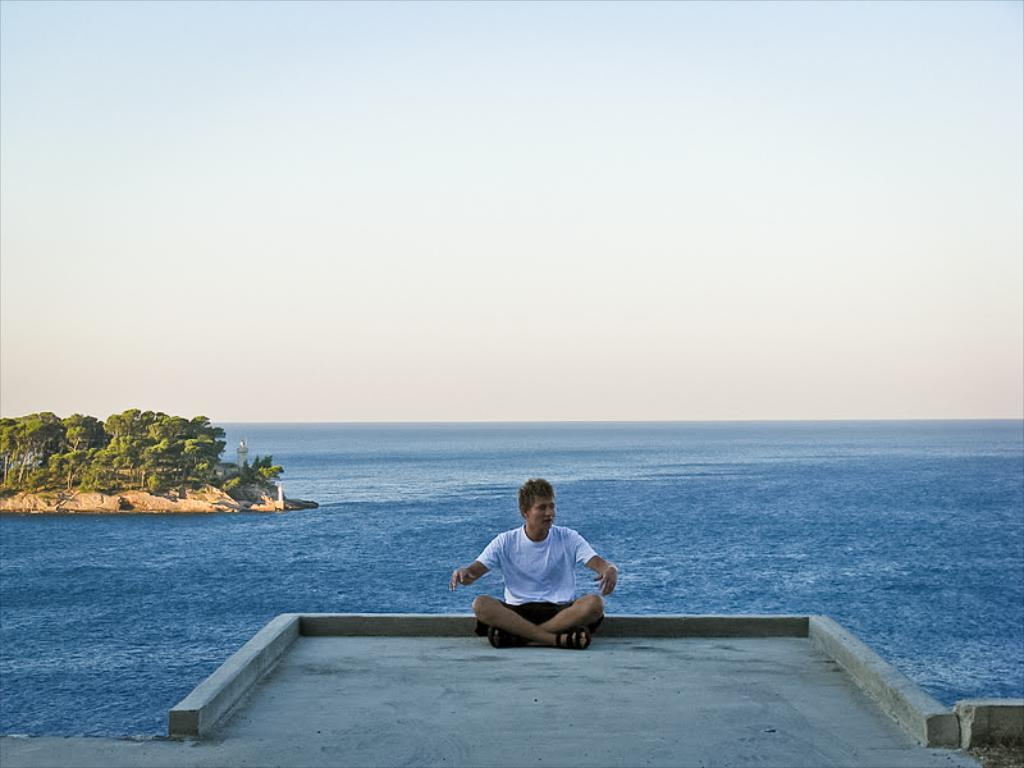What is the person in the image doing? The person is sitting on the floor in the image. What can be seen in the background of the image? There is water, ground with trees, and the sky visible in the image. What type of bait is the person using to catch the bear in the image? There is no bear or bait present in the image. What type of gun is the person holding in the image? There is no gun present in the image. 